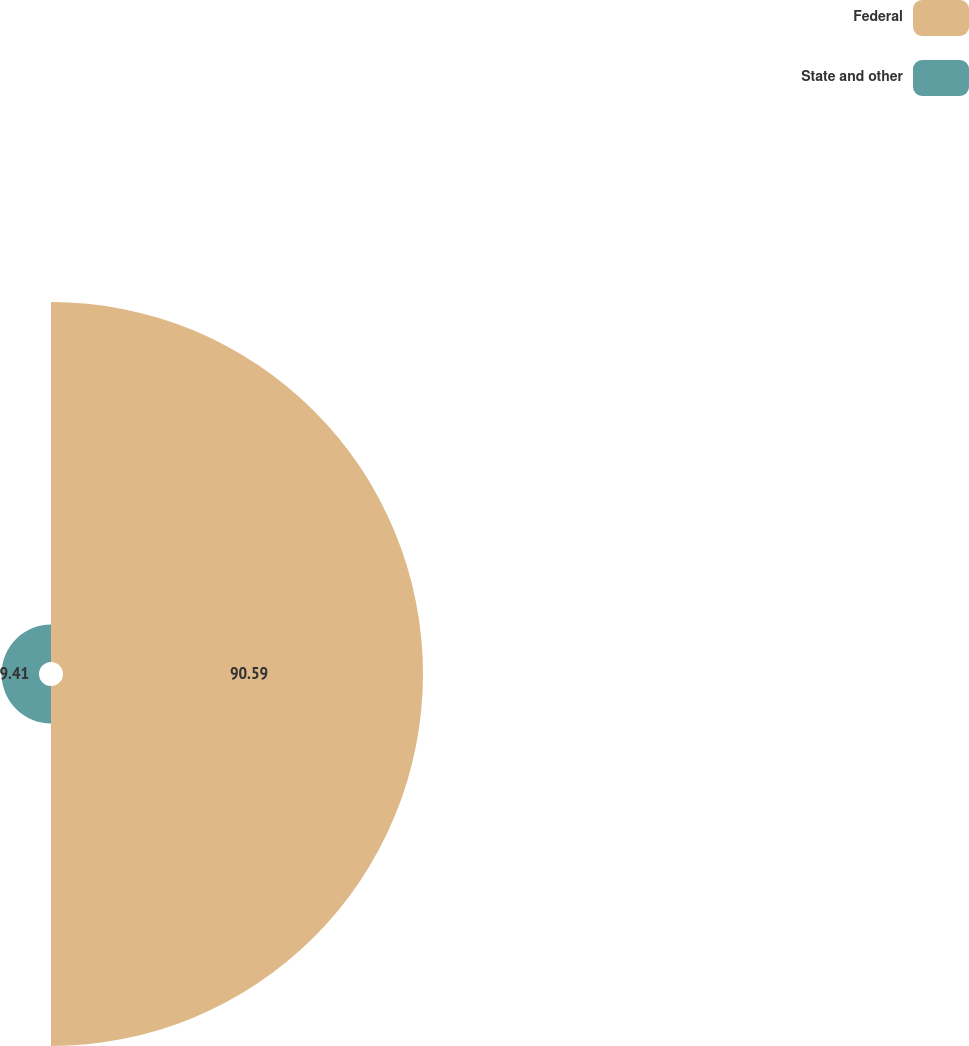Convert chart to OTSL. <chart><loc_0><loc_0><loc_500><loc_500><pie_chart><fcel>Federal<fcel>State and other<nl><fcel>90.59%<fcel>9.41%<nl></chart> 